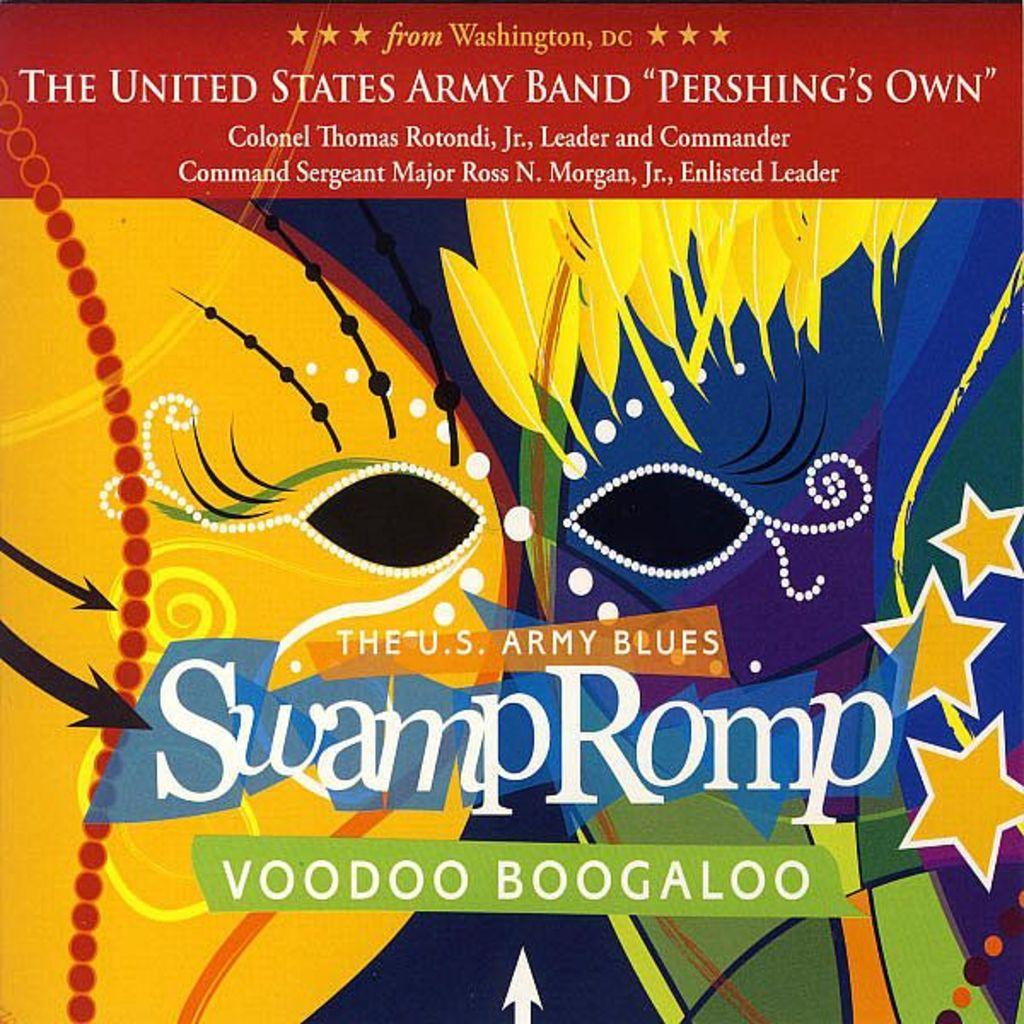<image>
Give a short and clear explanation of the subsequent image. A book of music called Swamp Romp Voodoo Boogaloo 